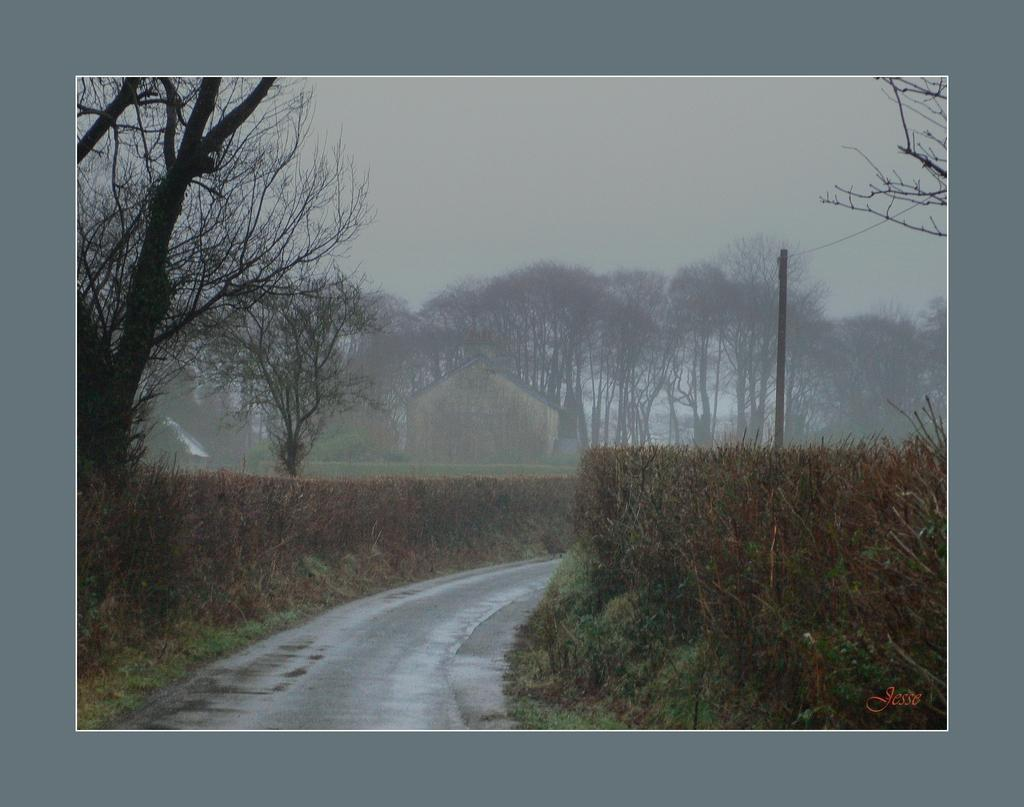What type of vegetation can be seen in the image? There are plants and trees in the image. What type of structure is present in the image? There is a house in the image. What else can be seen in the image besides the house and vegetation? There is a pole, wires, and a road visible in the image. What is visible in the background of the image? The sky and a road are visible in the background of the image. Can you tell me the reason why the pest is trying to scare away the scarecrow in the image? There is no pest or scarecrow present in the image, so it is not possible to answer that question. 